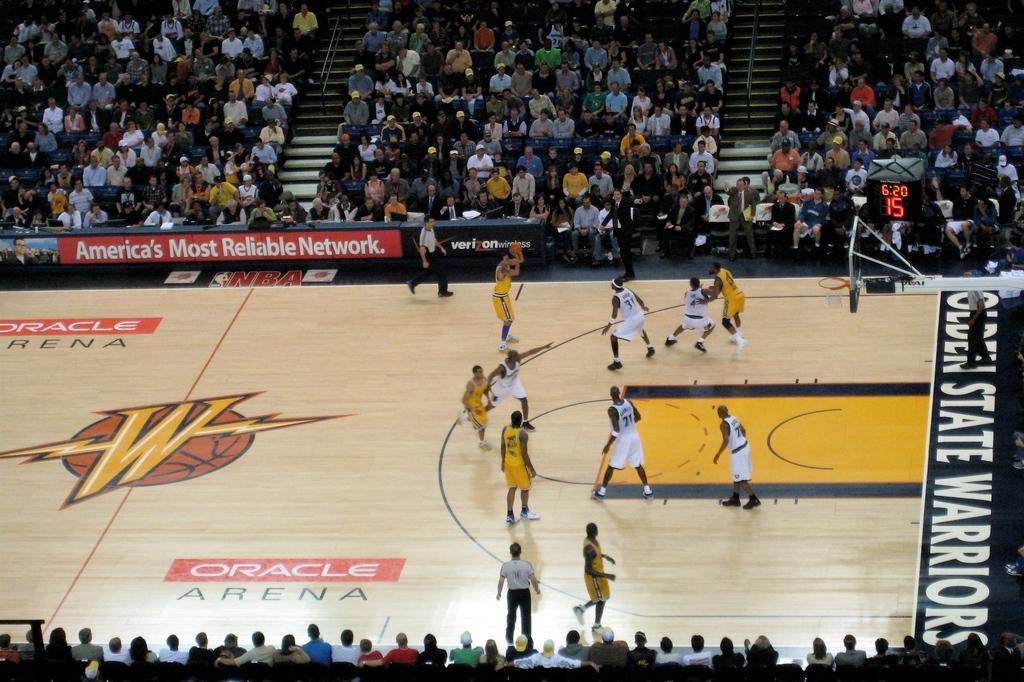What is the name of this arean?
Your response must be concise. Oracle. What team name is written on the arena floor?
Ensure brevity in your answer.  Golden state warriors. 